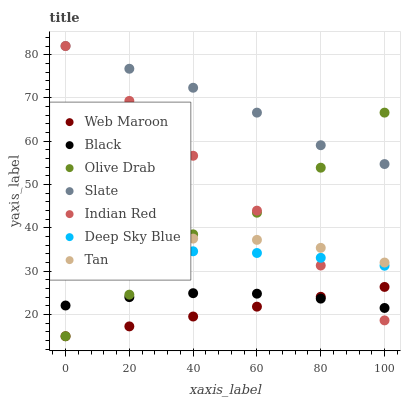Does Web Maroon have the minimum area under the curve?
Answer yes or no. Yes. Does Slate have the maximum area under the curve?
Answer yes or no. Yes. Does Slate have the minimum area under the curve?
Answer yes or no. No. Does Web Maroon have the maximum area under the curve?
Answer yes or no. No. Is Web Maroon the smoothest?
Answer yes or no. Yes. Is Olive Drab the roughest?
Answer yes or no. Yes. Is Slate the smoothest?
Answer yes or no. No. Is Slate the roughest?
Answer yes or no. No. Does Web Maroon have the lowest value?
Answer yes or no. Yes. Does Slate have the lowest value?
Answer yes or no. No. Does Indian Red have the highest value?
Answer yes or no. Yes. Does Web Maroon have the highest value?
Answer yes or no. No. Is Web Maroon less than Slate?
Answer yes or no. Yes. Is Deep Sky Blue greater than Web Maroon?
Answer yes or no. Yes. Does Olive Drab intersect Slate?
Answer yes or no. Yes. Is Olive Drab less than Slate?
Answer yes or no. No. Is Olive Drab greater than Slate?
Answer yes or no. No. Does Web Maroon intersect Slate?
Answer yes or no. No. 